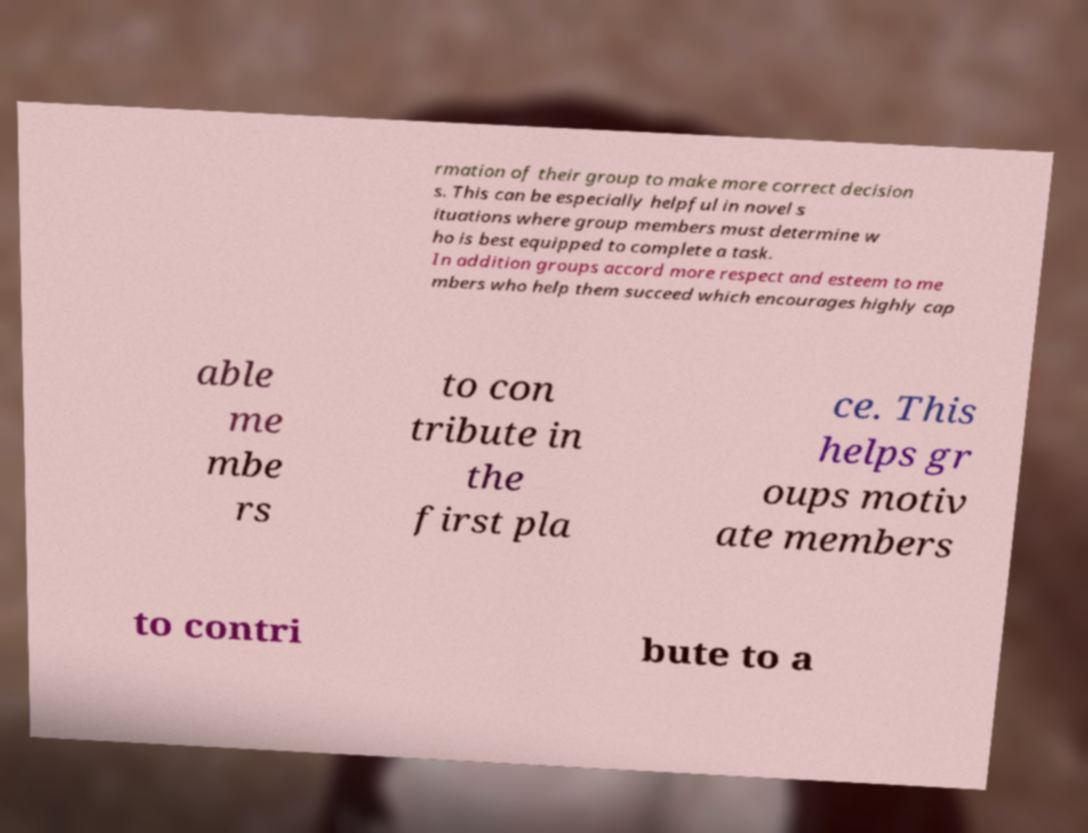Can you accurately transcribe the text from the provided image for me? rmation of their group to make more correct decision s. This can be especially helpful in novel s ituations where group members must determine w ho is best equipped to complete a task. In addition groups accord more respect and esteem to me mbers who help them succeed which encourages highly cap able me mbe rs to con tribute in the first pla ce. This helps gr oups motiv ate members to contri bute to a 